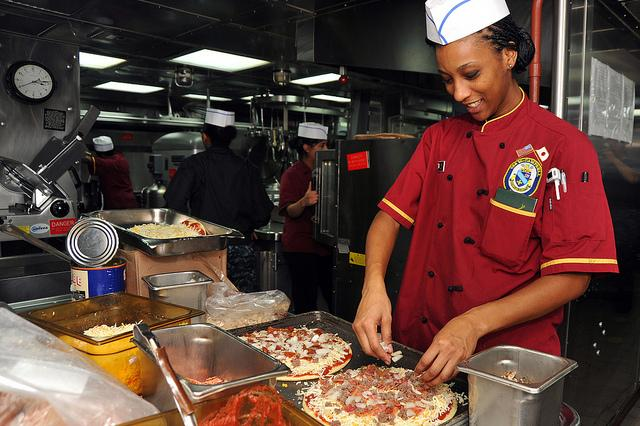What fungus is being added to this pie? Please explain your reasoning. mushrooms. The chef is putting slices of mushrooms on the pizza. 